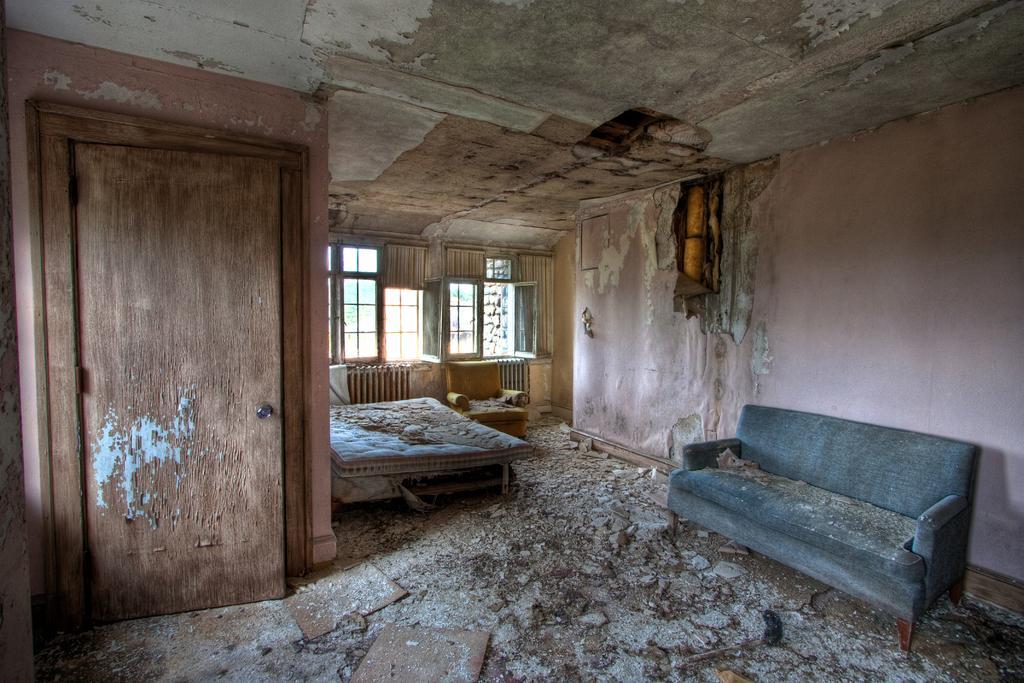What type of space is shown in the image? The image depicts a room. How would you describe the condition of the room? The room appears to be destroyed. Are there any specific features or objects in the room? Yes, there is a door, a sofa, and a bed in the room. Can you tell me how many parents are in the room? There is no reference to parents in the image, so it is not possible to determine how many are present. Is there a donkey in the room? There is no donkey present in the image. 